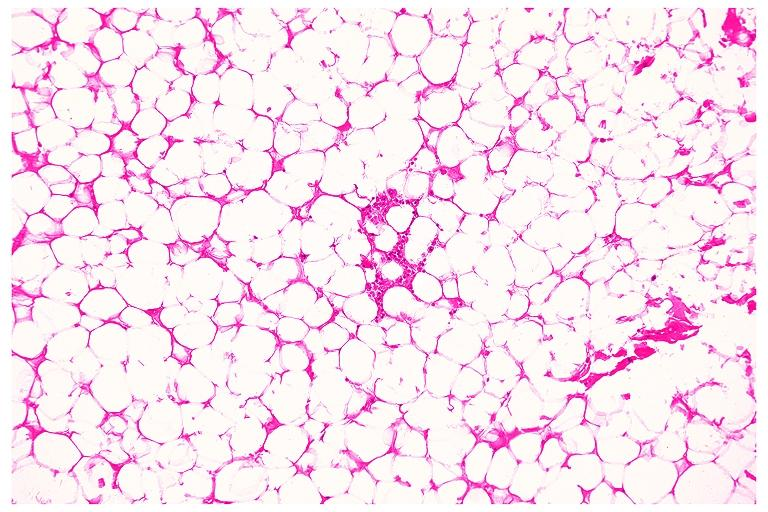does cut edge of mesentery show lipoma?
Answer the question using a single word or phrase. No 